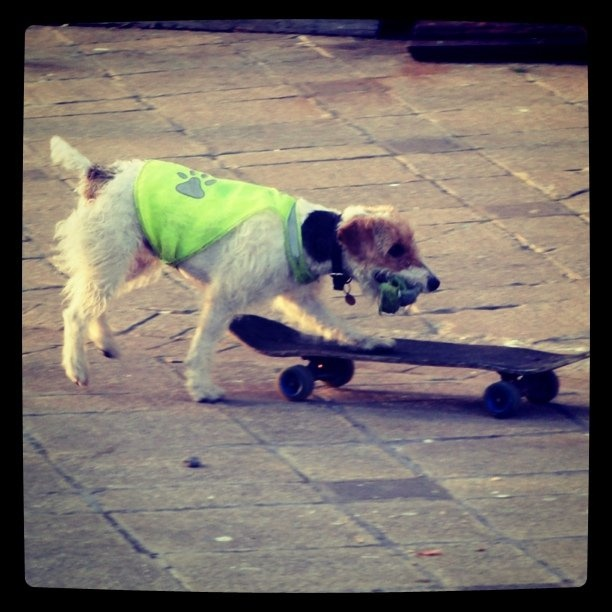Describe the objects in this image and their specific colors. I can see dog in black, khaki, darkgray, gray, and lightgreen tones and skateboard in black, navy, and purple tones in this image. 